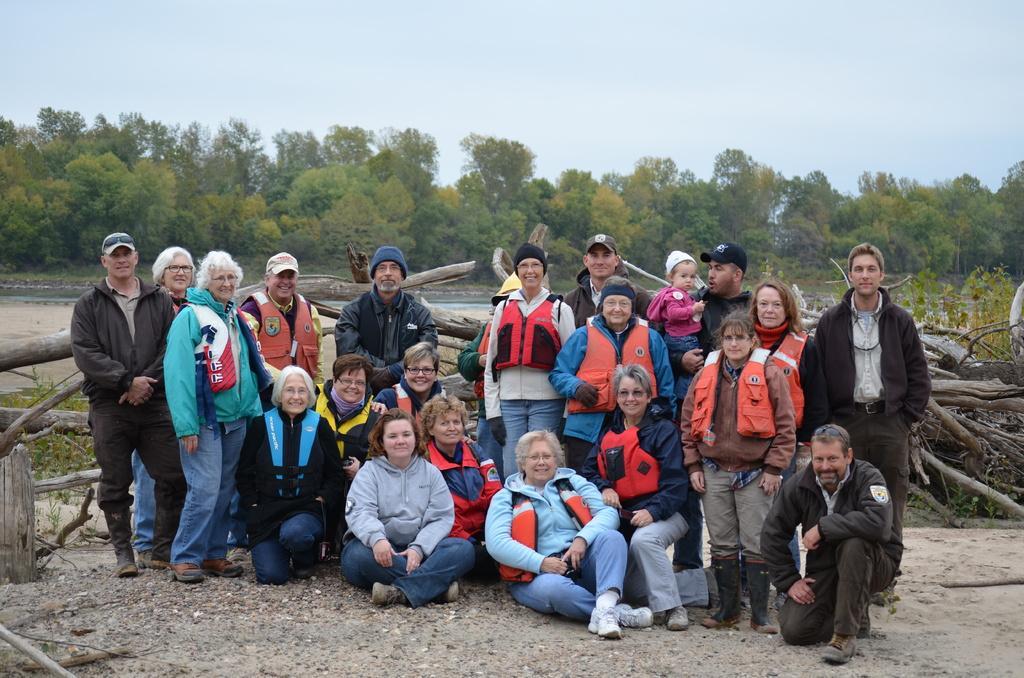How would you summarize this image in a sentence or two? A group of people are sitting, standing and laughing. Many of them were life jackets, behind them there are logs. In the middle there are green trees. At the top it is the sky. 